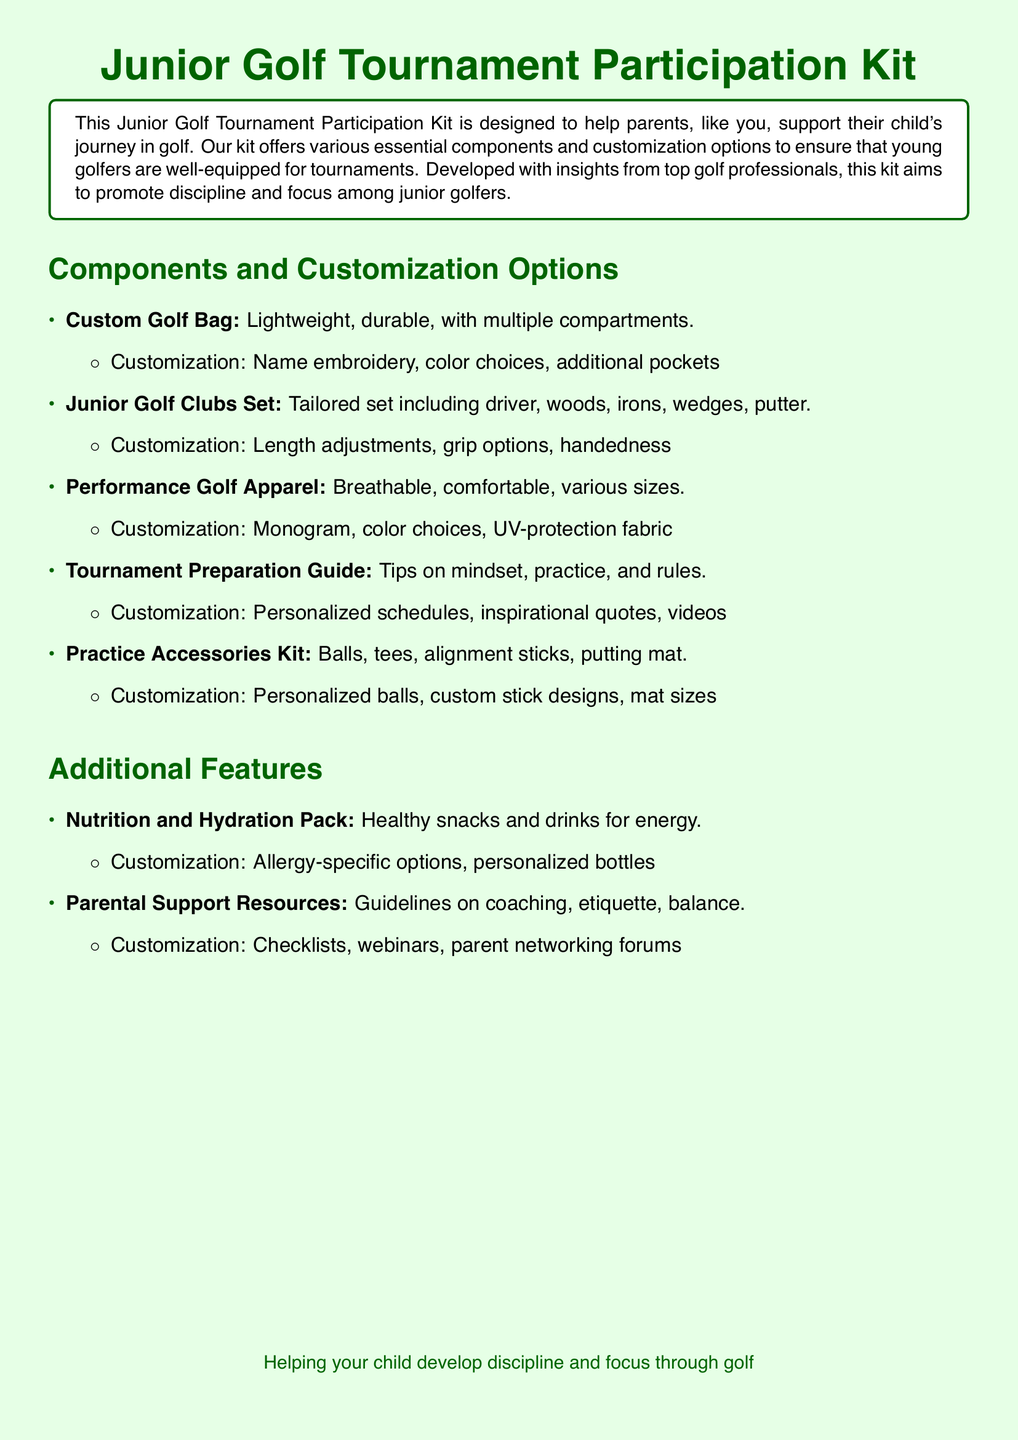What is included in the Junior Golf Tournament Participation Kit? The document lists various components such as a custom golf bag, junior golf clubs set, performance golf apparel, tournament preparation guide, and practice accessories kit.
Answer: Custom golf bag, junior golf clubs set, performance golf apparel, tournament preparation guide, practice accessories kit What customization options are available for the custom golf bag? The document specifies several customization options for the custom golf bag including name embroidery, color choices, and additional pockets.
Answer: Name embroidery, color choices, additional pockets How many items are listed under "Components and Customization Options"? The document presents five main items in this section.
Answer: Five What is the purpose of the Tournament Preparation Guide? The guide offers tips on mindset, practice, and rules which are essential for tournament readiness.
Answer: Tips on mindset, practice, and rules What does the Nutrition and Hydration Pack include? The document mentions healthy snacks and drinks for energy as part of this pack.
Answer: Healthy snacks and drinks What is one of the customization options for the Practice Accessories Kit? The document highlights personalized balls as a customization option for the Practice Accessories Kit.
Answer: Personalized balls What type of resources does the Parental Support Resources section provide? This section includes guidelines on coaching, etiquette, and balance to support parents.
Answer: Guidelines on coaching, etiquette, balance What material is mentioned for the performance golf apparel? The document states that the apparel is made from breathable and comfortable fabric.
Answer: Breathable, comfortable What additional features are included in the kit? Besides the main components, additional features include a nutrition pack and parental support resources.
Answer: Nutrition and hydration pack, parental support resources 